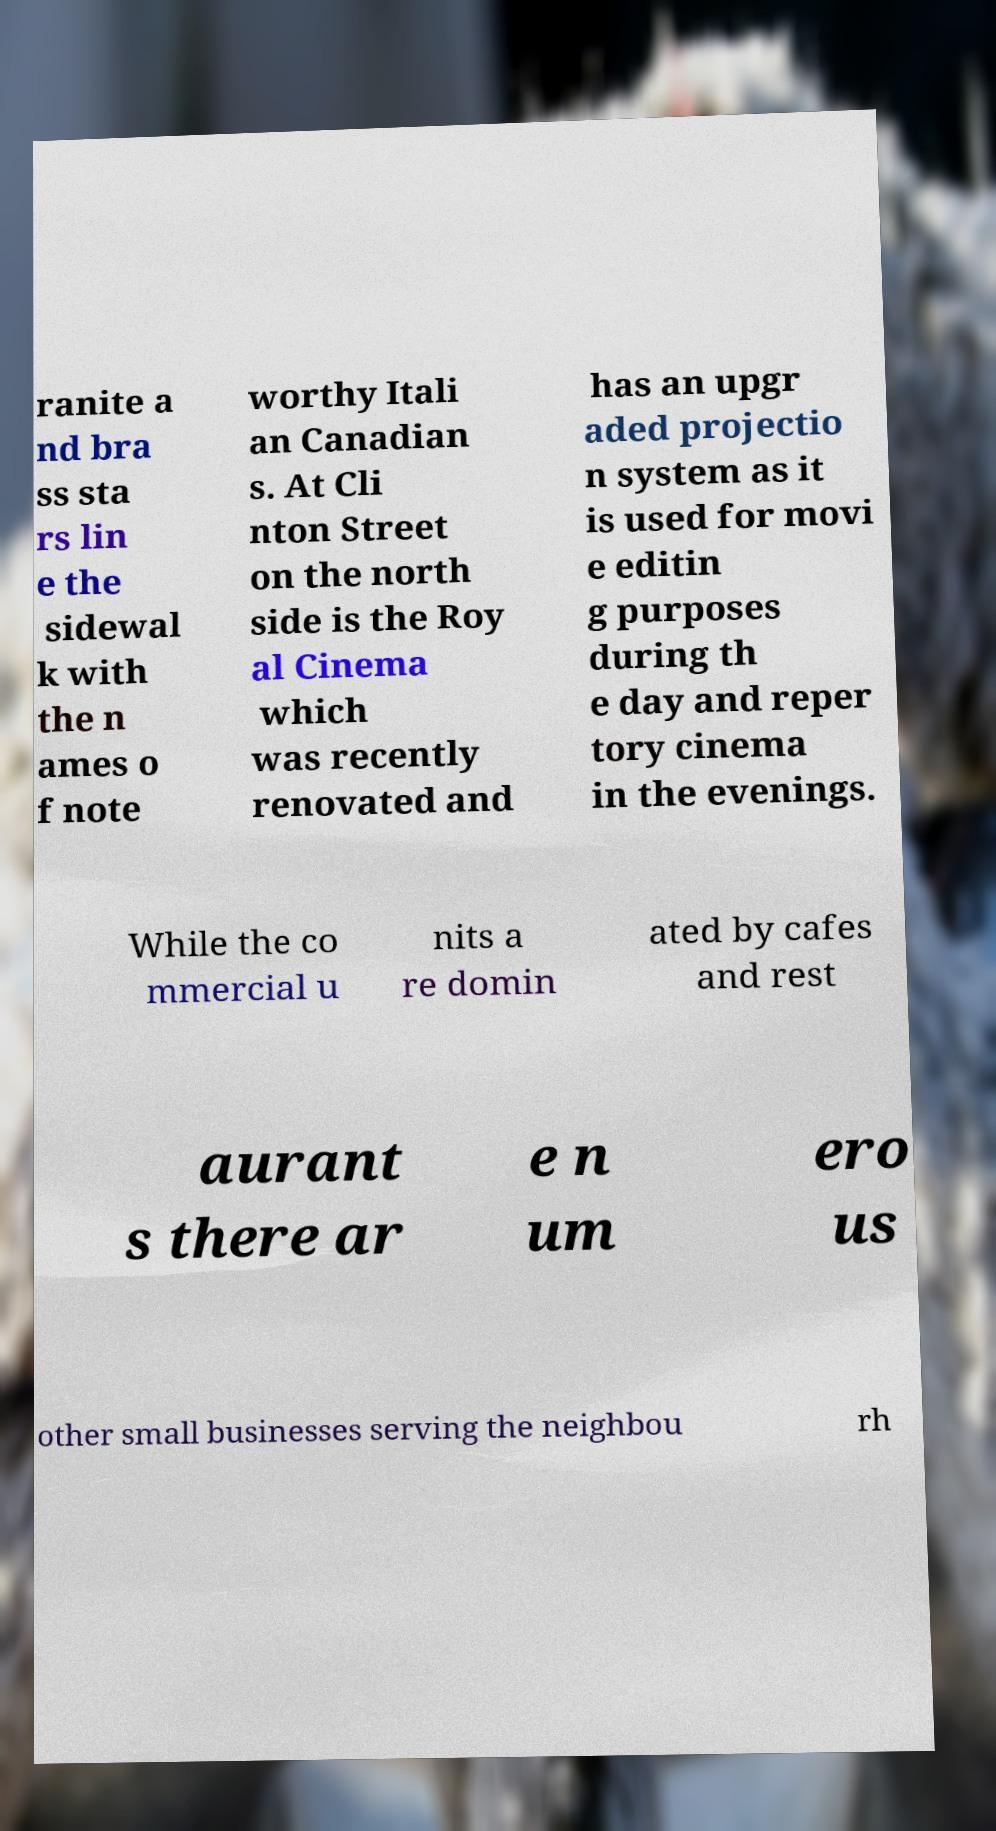Please read and relay the text visible in this image. What does it say? ranite a nd bra ss sta rs lin e the sidewal k with the n ames o f note worthy Itali an Canadian s. At Cli nton Street on the north side is the Roy al Cinema which was recently renovated and has an upgr aded projectio n system as it is used for movi e editin g purposes during th e day and reper tory cinema in the evenings. While the co mmercial u nits a re domin ated by cafes and rest aurant s there ar e n um ero us other small businesses serving the neighbou rh 